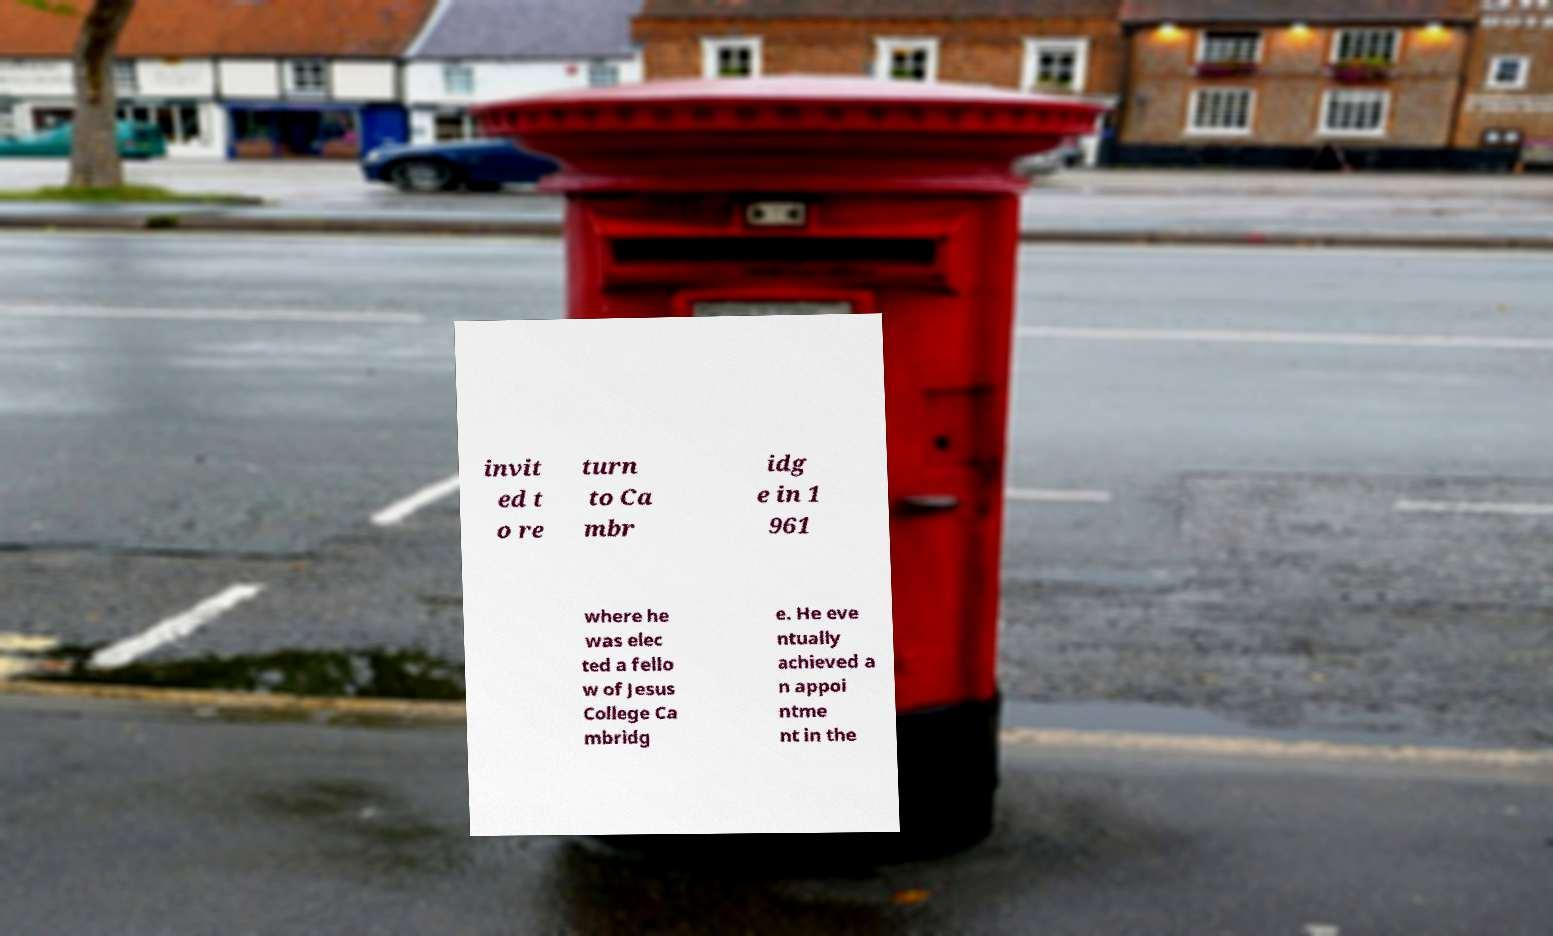Please read and relay the text visible in this image. What does it say? invit ed t o re turn to Ca mbr idg e in 1 961 where he was elec ted a fello w of Jesus College Ca mbridg e. He eve ntually achieved a n appoi ntme nt in the 